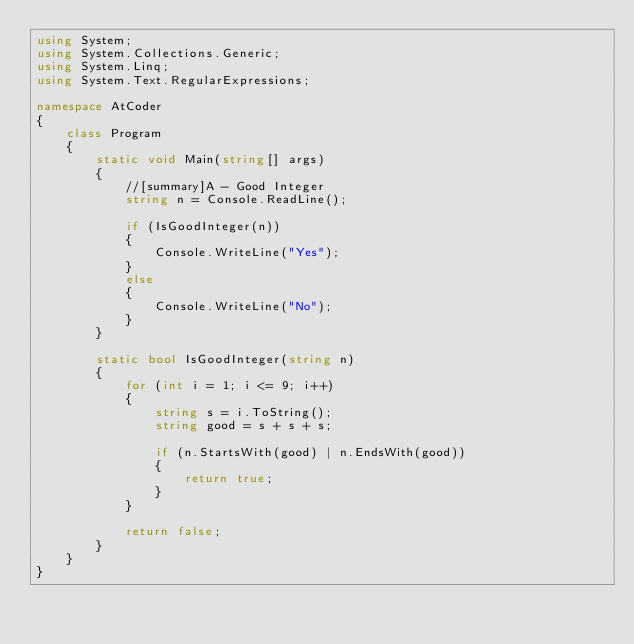Convert code to text. <code><loc_0><loc_0><loc_500><loc_500><_C#_>using System;
using System.Collections.Generic;
using System.Linq;
using System.Text.RegularExpressions;

namespace AtCoder
{
    class Program
    {
        static void Main(string[] args)
        {
            //[summary]A - Good Integer
            string n = Console.ReadLine();

            if (IsGoodInteger(n))
            {
                Console.WriteLine("Yes");
            }
            else
            {
                Console.WriteLine("No");
            }            
        }

        static bool IsGoodInteger(string n)
        {
            for (int i = 1; i <= 9; i++)
            {
                string s = i.ToString();
                string good = s + s + s;

                if (n.StartsWith(good) | n.EndsWith(good))
                {
                    return true;
                }
            }

            return false;
        }
    }
}</code> 